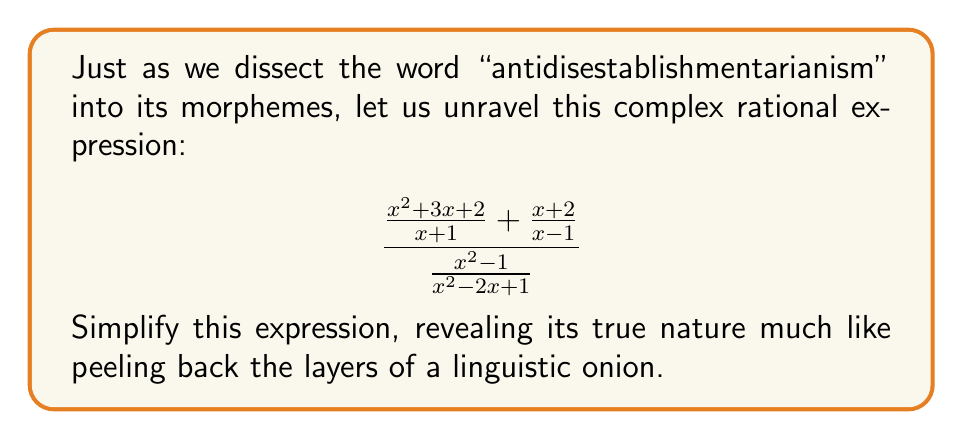Can you answer this question? Let's approach this step-by-step, as if we're analyzing the components of our multisyllabic word:

1) First, let's simplify the numerator. We need to find a common denominator:
   $$\frac{x^2+3x+2}{x+1} + \frac{x+2}{x-1} = \frac{(x^2+3x+2)(x-1) + (x+2)(x+1)}{(x+1)(x-1)}$$

2) Expand the numerator:
   $$\frac{(x^3+2x^2-x-2) + (x^2+3x+2)}{x^2-1}$$

3) Combine like terms in the numerator:
   $$\frac{x^3+3x^2+2x}{x^2-1}$$

4) Now, our expression looks like:
   $$\frac{\frac{x^3+3x^2+2x}{x^2-1}}{\frac{x^2-1}{x^2-2x+1}}$$

5) To divide fractions, we multiply by the reciprocal:
   $$\frac{x^3+3x^2+2x}{x^2-1} \cdot \frac{x^2-2x+1}{x^2-1}$$

6) The $(x^2-1)$ terms cancel out:
   $$\frac{(x^3+3x^2+2x)(x^2-2x+1)}{(x^2-1)^2}$$

7) Expand the numerator:
   $$\frac{x^5+x^4-x^3+3x^4-6x^3+3x^2+2x^3-4x^2+2x}{(x^2-1)^2}$$

8) Combine like terms in the numerator:
   $$\frac{x^5+4x^4-5x^3-x^2+2x}{(x^2-1)^2}$$

9) Factor out the greatest common factor in the numerator:
   $$\frac{x(x^4+4x^3-5x^2-x+2)}{(x^2-1)^2}$$

Thus, we've simplified our complex rational expression, much like we would break down a complex word into its root, prefixes, and suffixes.
Answer: $$\frac{x(x^4+4x^3-5x^2-x+2)}{(x^2-1)^2}$$ 